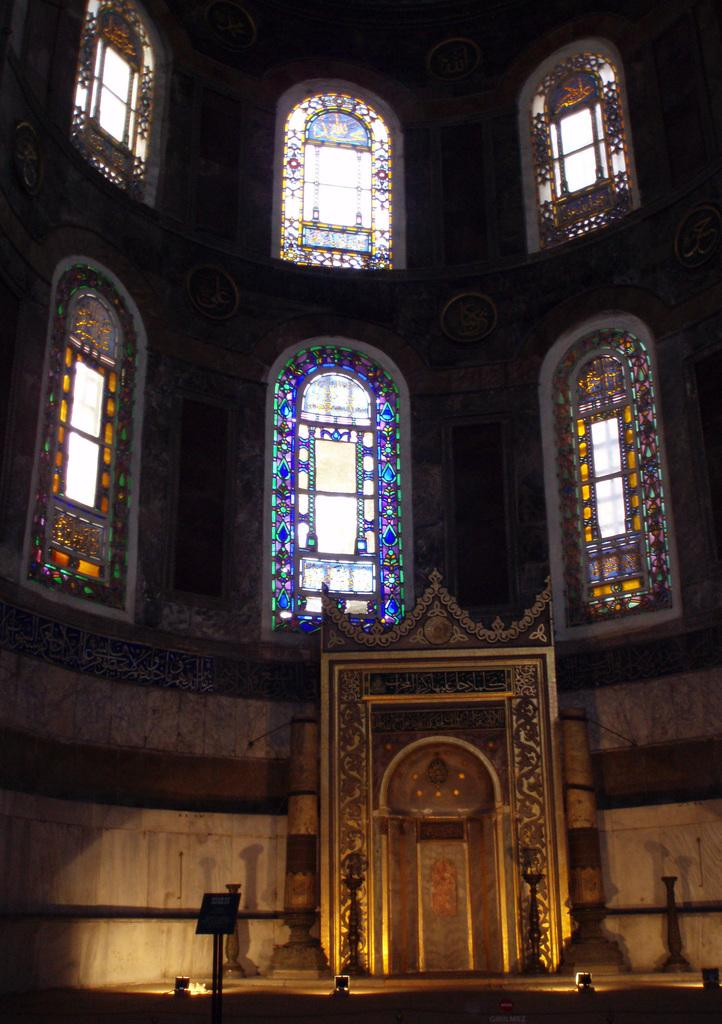What type of structure is visible in the image? There is a building in the image. What architectural feature can be seen in the building? There is stained glass in the image. What type of lighting is present in the image? There are lamps in the image. What piece of furniture is visible in the image? There is a lectern in the image. What story is being told through the stained glass in the image? There is no story being told through the stained glass in the image; it is simply a decorative feature. 